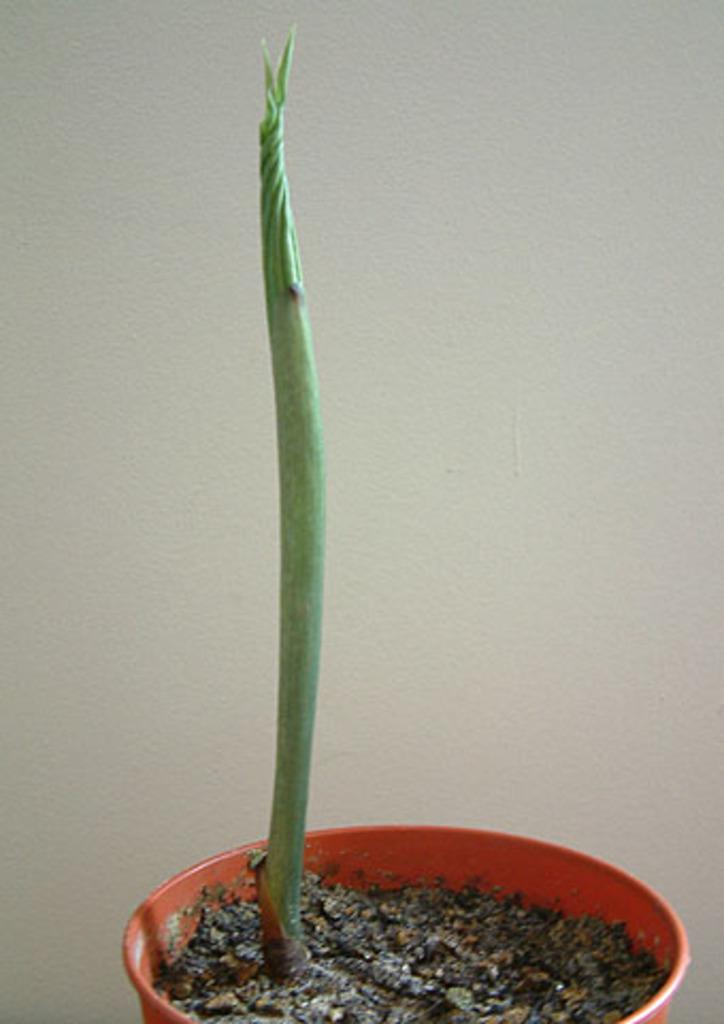What type of plant is in the image? There is a green plant in the image. How is the plant contained in the image? The plant is in a pot. What color is the soil in the pot? The soil in the pot is black. What can be seen in the background of the image? There is a white-colored wall in the background of the image. How many snails are crawling on the plant in the image? There are no snails visible in the image; it only shows a green plant in a pot with black soil. What type of bird can be seen perched on the plant in the image? There are no birds present in the image; it only shows a green plant in a pot with black soil. 